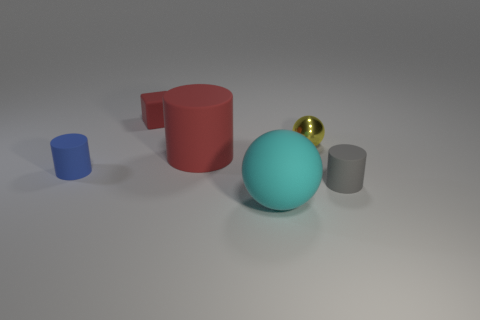What size is the other metal object that is the same shape as the big cyan thing?
Your response must be concise. Small. What color is the rubber object that is both behind the big cyan matte sphere and to the right of the large red matte cylinder?
Your answer should be compact. Gray. How many objects are either red rubber things that are left of the large red cylinder or gray rubber objects?
Your answer should be very brief. 2. What color is the small thing that is the same shape as the big cyan thing?
Provide a short and direct response. Yellow. Is the shape of the big cyan thing the same as the tiny rubber thing behind the blue thing?
Keep it short and to the point. No. How many things are either tiny things behind the yellow ball or objects in front of the red cylinder?
Keep it short and to the point. 4. Are there fewer gray cylinders behind the yellow metallic sphere than shiny balls?
Give a very brief answer. Yes. Is the material of the big cyan sphere the same as the small cylinder that is left of the small red matte block?
Your answer should be very brief. Yes. What is the tiny red object made of?
Ensure brevity in your answer.  Rubber. What material is the big object in front of the tiny matte cylinder that is on the right side of the tiny cylinder left of the cyan thing?
Your answer should be compact. Rubber. 